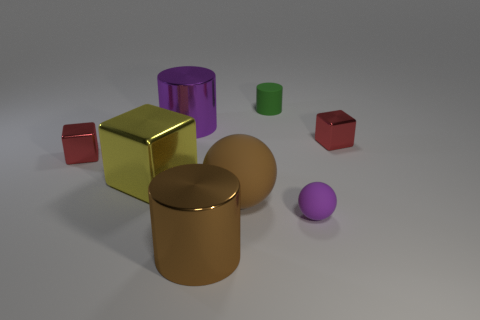Subtract all yellow blocks. How many blocks are left? 2 Subtract all brown cylinders. How many cylinders are left? 2 Subtract 1 cylinders. How many cylinders are left? 2 Add 2 rubber spheres. How many objects exist? 10 Subtract all blocks. How many objects are left? 5 Subtract all brown cylinders. How many purple spheres are left? 1 Add 4 tiny spheres. How many tiny spheres are left? 5 Add 2 shiny blocks. How many shiny blocks exist? 5 Subtract 0 gray balls. How many objects are left? 8 Subtract all brown blocks. Subtract all yellow balls. How many blocks are left? 3 